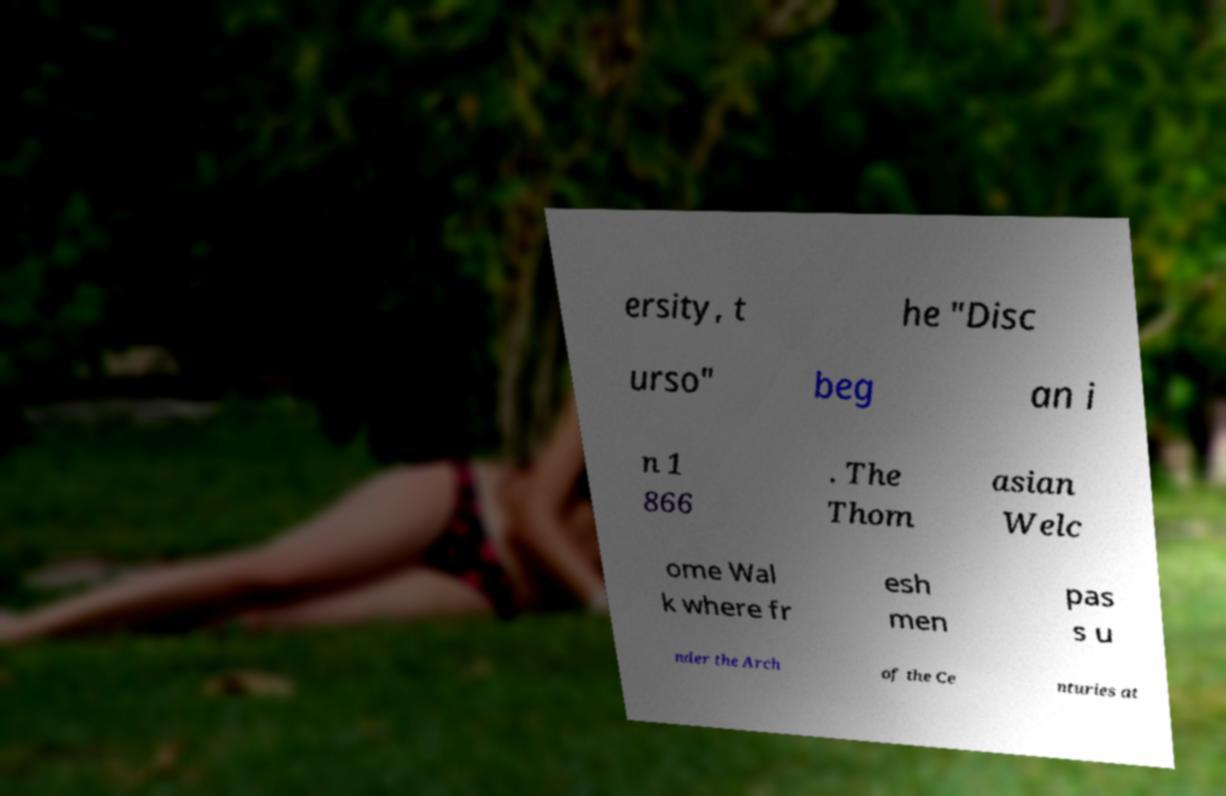Can you accurately transcribe the text from the provided image for me? ersity, t he "Disc urso" beg an i n 1 866 . The Thom asian Welc ome Wal k where fr esh men pas s u nder the Arch of the Ce nturies at 